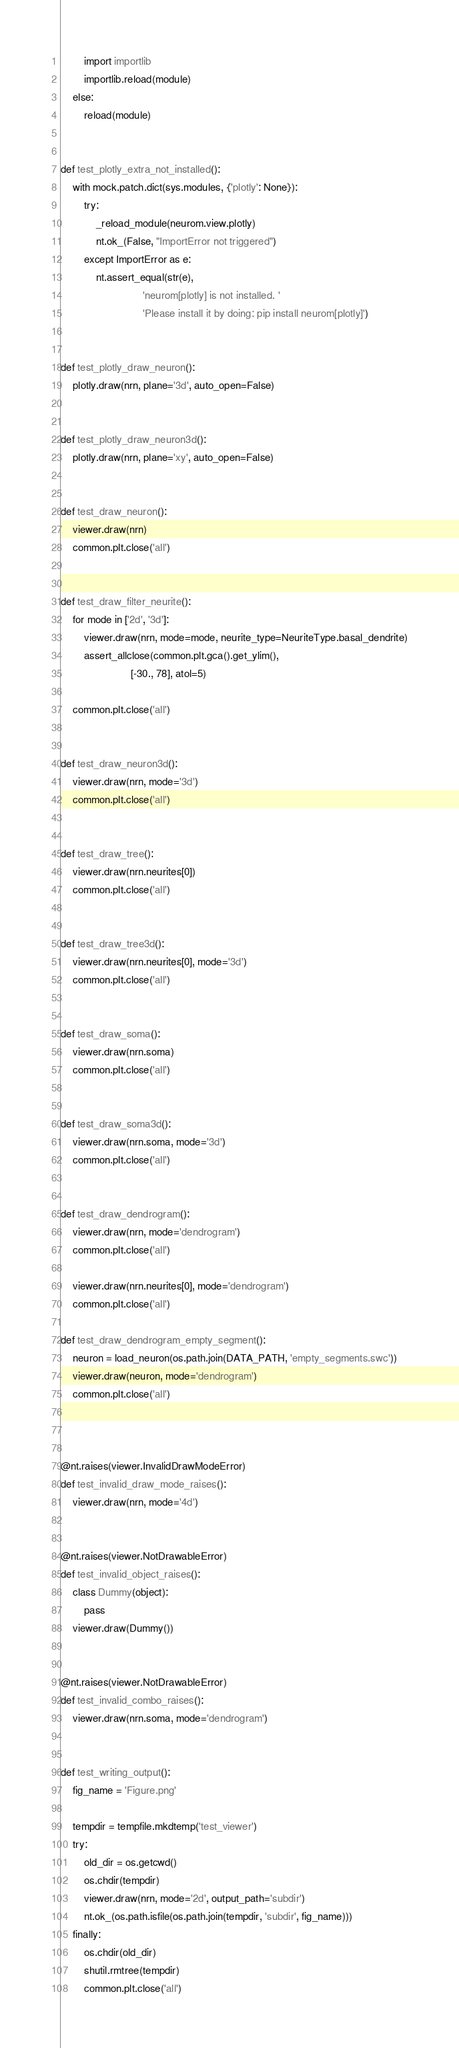Convert code to text. <code><loc_0><loc_0><loc_500><loc_500><_Python_>        import importlib
        importlib.reload(module)
    else:
        reload(module)


def test_plotly_extra_not_installed():
    with mock.patch.dict(sys.modules, {'plotly': None}):
        try:
            _reload_module(neurom.view.plotly)
            nt.ok_(False, "ImportError not triggered")
        except ImportError as e:
            nt.assert_equal(str(e),
                            'neurom[plotly] is not installed. '
                            'Please install it by doing: pip install neurom[plotly]')


def test_plotly_draw_neuron():
    plotly.draw(nrn, plane='3d', auto_open=False)


def test_plotly_draw_neuron3d():
    plotly.draw(nrn, plane='xy', auto_open=False)


def test_draw_neuron():
    viewer.draw(nrn)
    common.plt.close('all')


def test_draw_filter_neurite():
    for mode in ['2d', '3d']:
        viewer.draw(nrn, mode=mode, neurite_type=NeuriteType.basal_dendrite)
        assert_allclose(common.plt.gca().get_ylim(),
                        [-30., 78], atol=5)

    common.plt.close('all')


def test_draw_neuron3d():
    viewer.draw(nrn, mode='3d')
    common.plt.close('all')


def test_draw_tree():
    viewer.draw(nrn.neurites[0])
    common.plt.close('all')


def test_draw_tree3d():
    viewer.draw(nrn.neurites[0], mode='3d')
    common.plt.close('all')


def test_draw_soma():
    viewer.draw(nrn.soma)
    common.plt.close('all')


def test_draw_soma3d():
    viewer.draw(nrn.soma, mode='3d')
    common.plt.close('all')


def test_draw_dendrogram():
    viewer.draw(nrn, mode='dendrogram')
    common.plt.close('all')

    viewer.draw(nrn.neurites[0], mode='dendrogram')
    common.plt.close('all')

def test_draw_dendrogram_empty_segment():
    neuron = load_neuron(os.path.join(DATA_PATH, 'empty_segments.swc'))
    viewer.draw(neuron, mode='dendrogram')
    common.plt.close('all')



@nt.raises(viewer.InvalidDrawModeError)
def test_invalid_draw_mode_raises():
    viewer.draw(nrn, mode='4d')


@nt.raises(viewer.NotDrawableError)
def test_invalid_object_raises():
    class Dummy(object):
        pass
    viewer.draw(Dummy())


@nt.raises(viewer.NotDrawableError)
def test_invalid_combo_raises():
    viewer.draw(nrn.soma, mode='dendrogram')


def test_writing_output():
    fig_name = 'Figure.png'

    tempdir = tempfile.mkdtemp('test_viewer')
    try:
        old_dir = os.getcwd()
        os.chdir(tempdir)
        viewer.draw(nrn, mode='2d', output_path='subdir')
        nt.ok_(os.path.isfile(os.path.join(tempdir, 'subdir', fig_name)))
    finally:
        os.chdir(old_dir)
        shutil.rmtree(tempdir)
        common.plt.close('all')
</code> 